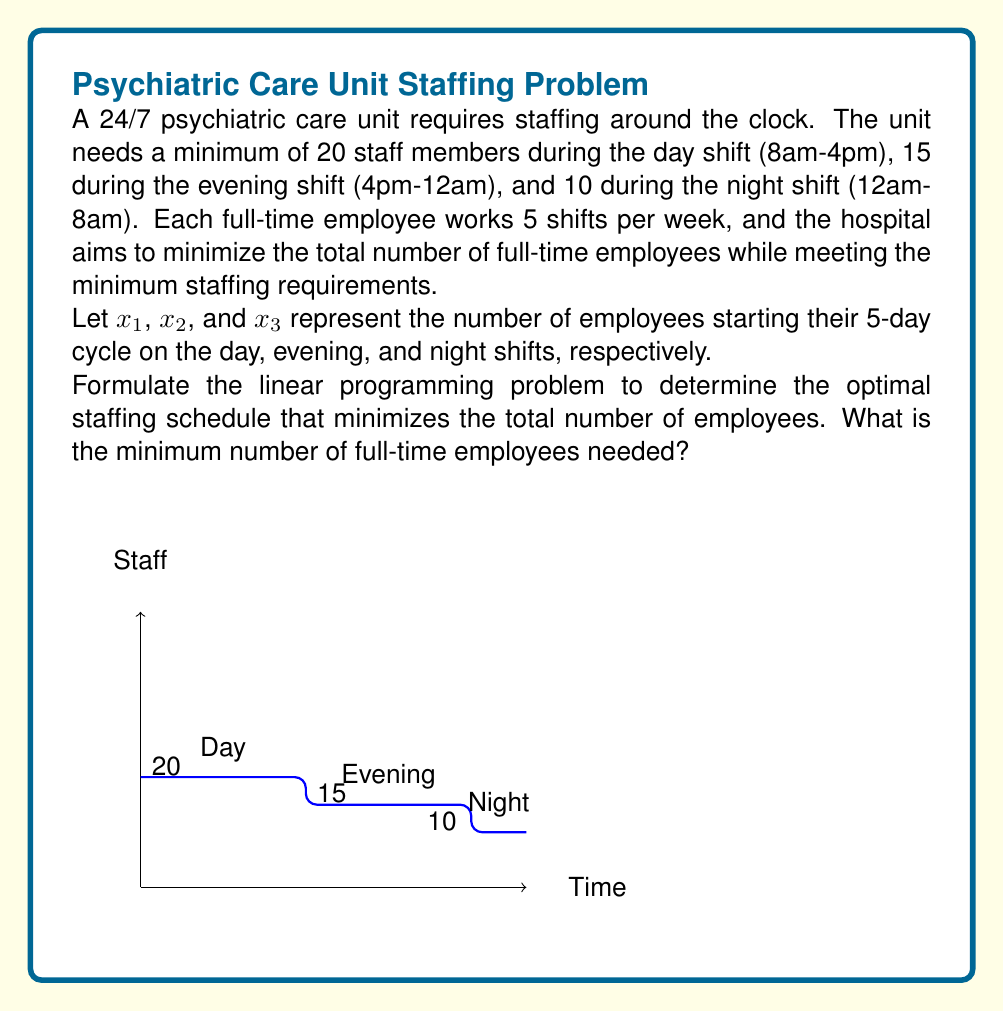What is the answer to this math problem? To solve this linear programming problem, we need to:

1. Define the objective function
2. Set up the constraints
3. Solve the system

Step 1: Objective function
We want to minimize the total number of employees:
$$\text{Minimize } Z = x_1 + x_2 + x_3$$

Step 2: Constraints
For each shift, we need to ensure that the number of staff members meets or exceeds the minimum requirement. Each employee works 5 consecutive shifts starting from their assigned shift.

Day shift (8am-4pm):
$$x_1 + x_2 + x_3 \geq 20$$

Evening shift (4pm-12am):
$$x_1 + x_2 + x_3 \geq 15$$

Night shift (12am-8am):
$$x_1 + x_2 + x_3 \geq 10$$

Non-negativity constraints:
$$x_1, x_2, x_3 \geq 0$$

Step 3: Solving the system
From the constraints, we can see that the day shift has the highest requirement of 20 staff members. Since this constraint must be satisfied and it's stricter than the other two, we can conclude that:

$$x_1 + x_2 + x_3 = 20$$

This solution satisfies all constraints and minimizes the objective function.

Therefore, the minimum number of full-time employees needed is 20, regardless of how they are distributed among the starting shifts.
Answer: 20 full-time employees 